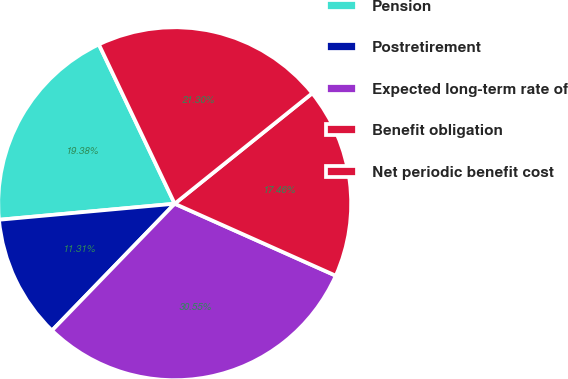Convert chart. <chart><loc_0><loc_0><loc_500><loc_500><pie_chart><fcel>Pension<fcel>Postretirement<fcel>Expected long-term rate of<fcel>Benefit obligation<fcel>Net periodic benefit cost<nl><fcel>19.38%<fcel>11.31%<fcel>30.55%<fcel>17.46%<fcel>21.3%<nl></chart> 